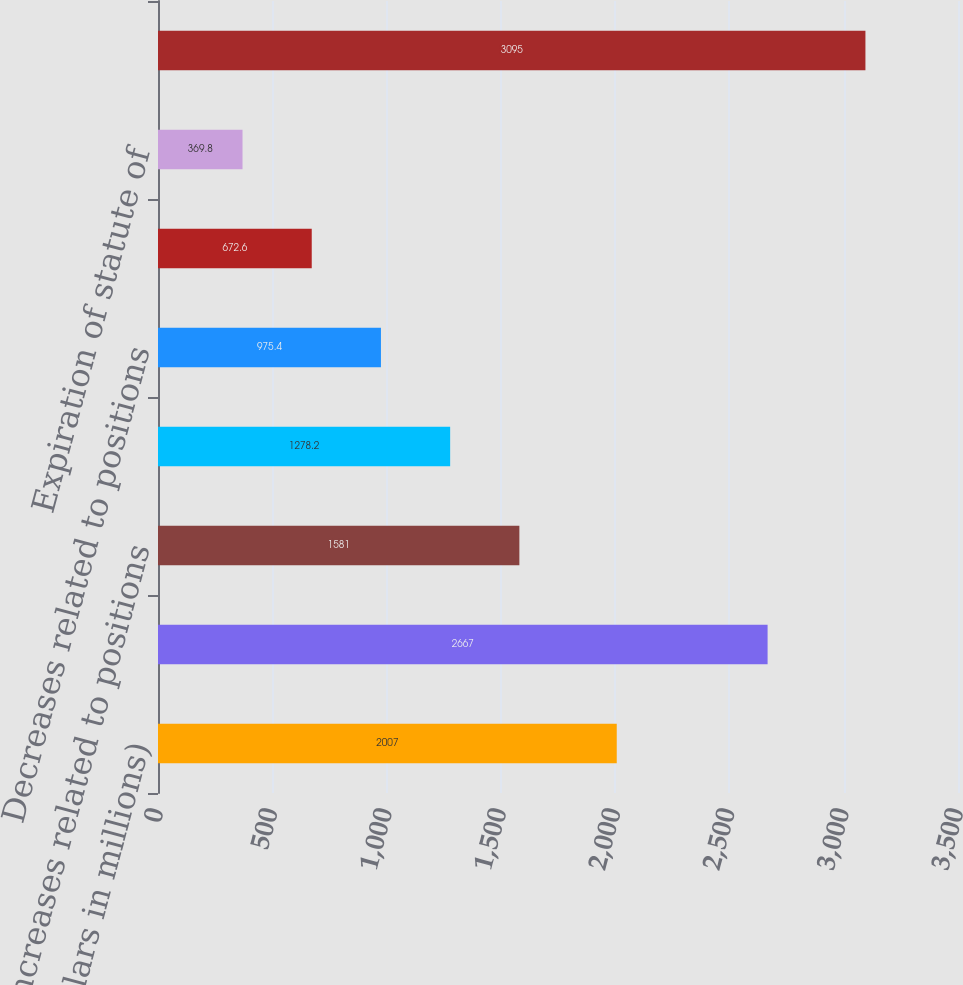Convert chart to OTSL. <chart><loc_0><loc_0><loc_500><loc_500><bar_chart><fcel>(Dollars in millions)<fcel>Beginning balance<fcel>Increases related to positions<fcel>Positions acquired or assumed<fcel>Decreases related to positions<fcel>Settlements<fcel>Expiration of statute of<fcel>Ending balance<nl><fcel>2007<fcel>2667<fcel>1581<fcel>1278.2<fcel>975.4<fcel>672.6<fcel>369.8<fcel>3095<nl></chart> 